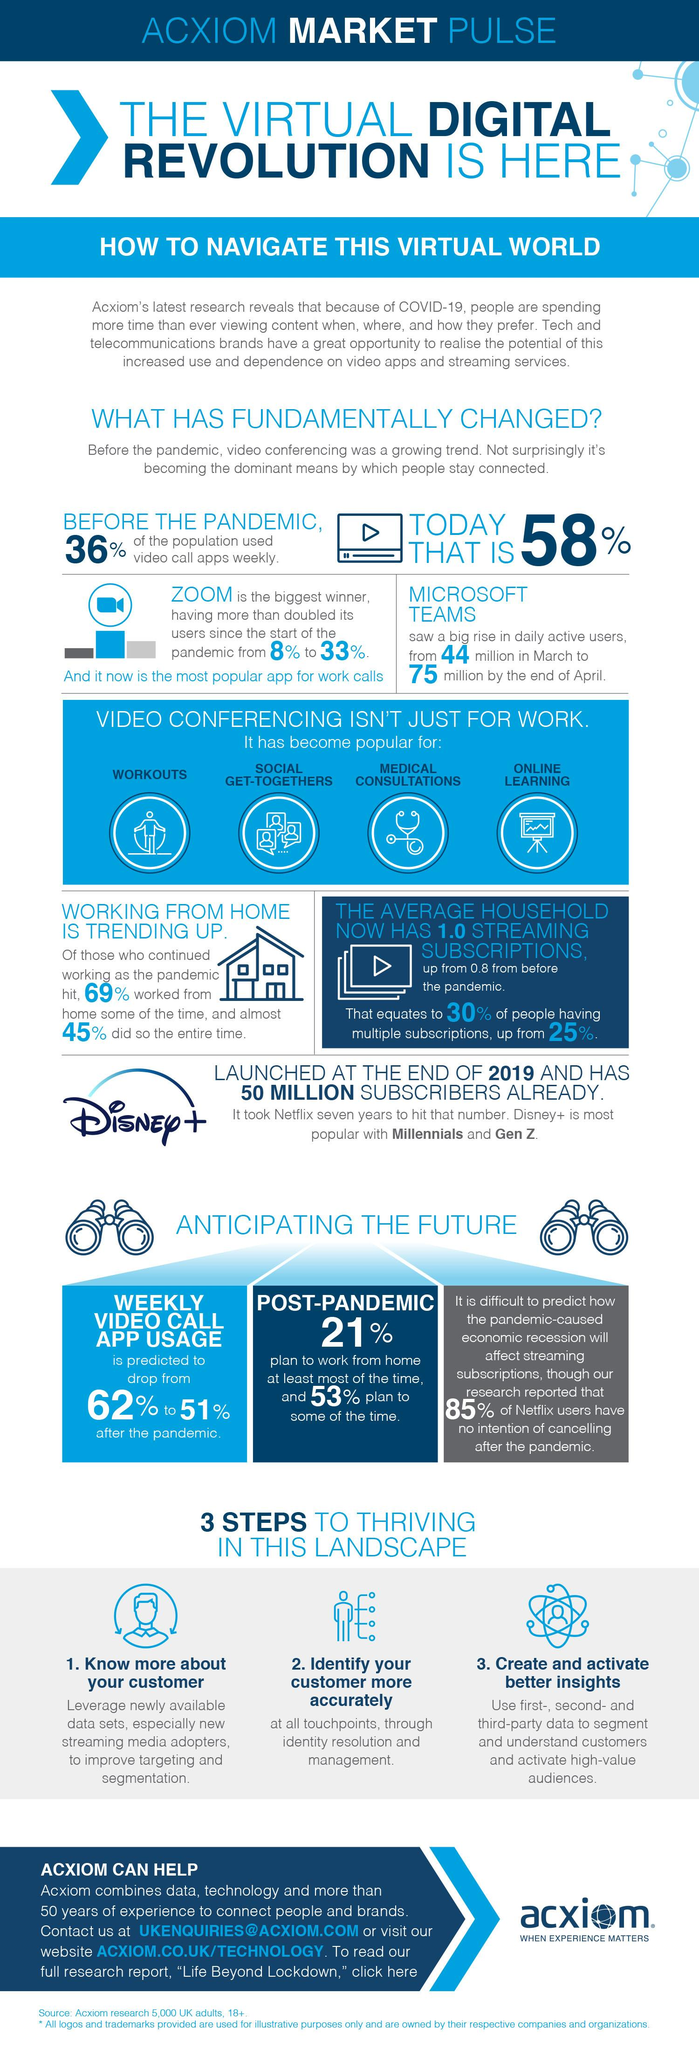Indicate a few pertinent items in this graphic. During the pandemic, it is estimated that approximately 55% of people worked from home for the entire time. During the ongoing global pandemic, people are utilizing video conferencing as a means of connecting with one another despite physical distance. Disney+ is the application that has surpassed Netflix in popularity within one year of its launch. Zoom is currently the most commonly used application for work-related calls, according to recent data. The use of the Microsoft Teams app increased by a significant percentage from 44 million in March to 75 million by the end of April, representing a significant growth in adoption of the app. 